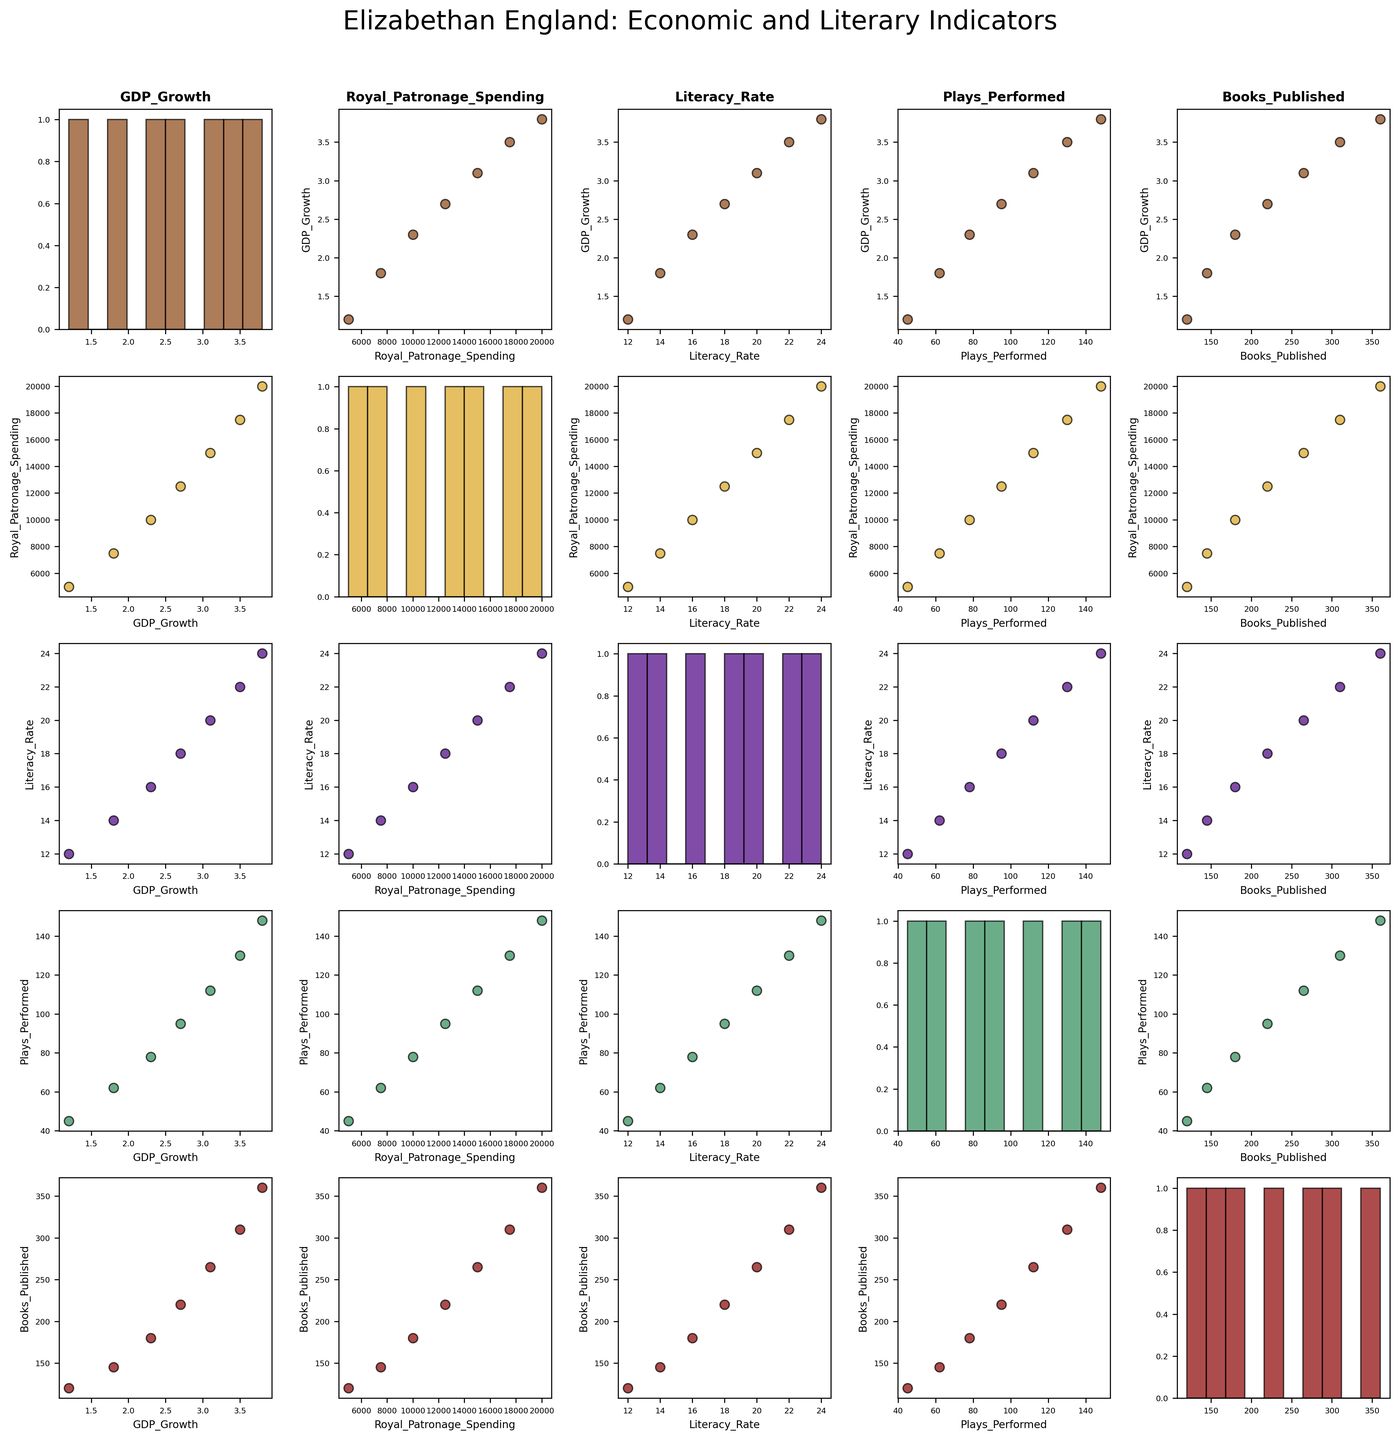What does the scatter plot matrix title reveal about the context of the data? The title "Elizabethan England: Economic and Literary Indicators" suggests that the plot matrix is exploring relationships between economic indicators (GDP growth and Royal Patronage Spending) and literary indicators (Literacy Rate, Plays Performed, and Books Published) during Elizabethan England.
Answer: The plot matrix explores relationships between economic and literary indicators in Elizabethan England How many variables are being compared in the scatter plot matrix? The scatter plot matrix contains a grid of scatter plots comparing five variables: GDP Growth, Royal Patronage Spending, Literacy Rate, Plays Performed, and Books Published.
Answer: Five variables Which variables are on the x-axis and y-axis of the scatter plot at the second row and third column? In the scatter plot matrix, selecting the second row and third column places Royal Patronage Spending on the y-axis and Literacy Rate on the x-axis.
Answer: Royal Patronage Spending (y-axis) and Literacy Rate (x-axis) What is the overall trend between Royal Patronage Spending and Plays Performed? The scatter plot shows a positive trend, indicating that as Royal Patronage Spending increases, the number of Plays Performed also increases.
Answer: Positive trend Which histogram is in the second column and second row? Looking at the second column and second row of the scatter plot matrix, the histogram represents the distribution of Royal Patronage Spending.
Answer: Royal Patronage Spending How does Literacy Rate correlate with GDP Growth based on the visual trend observed? The scatter plot in the matrix indicates a positive correlation, with Literacy Rate increasing as GDP Growth increases.
Answer: Positive correlation What is the range of data points for Books Published as seen in its histogram? The histogram for Books Published, found in the last column, ranges from around 120 to 360.
Answer: 120 to 360 Compare the spread of the data in Plays Performed and Books Published. Which one has a wider range? Looking at the scatter plots and histograms, Books Published has a wider range (120 to 360) compared to Plays Performed (45 to 148).
Answer: Books Published Based on the scatter plot between Literacy Rate and Books Published, what is the nature of their relationship? The scatter plot shows a positive relationship, where an increase in Literacy Rate corresponds with an increase in Books Published.
Answer: Positive relationship Which variable seems to have the most direct visual impact on GDP Growth? By observing the scatter plots, Royal Patronage Spending seems to show a strong visual correlation with GDP Growth, suggesting a direct impact.
Answer: Royal Patronage Spending 